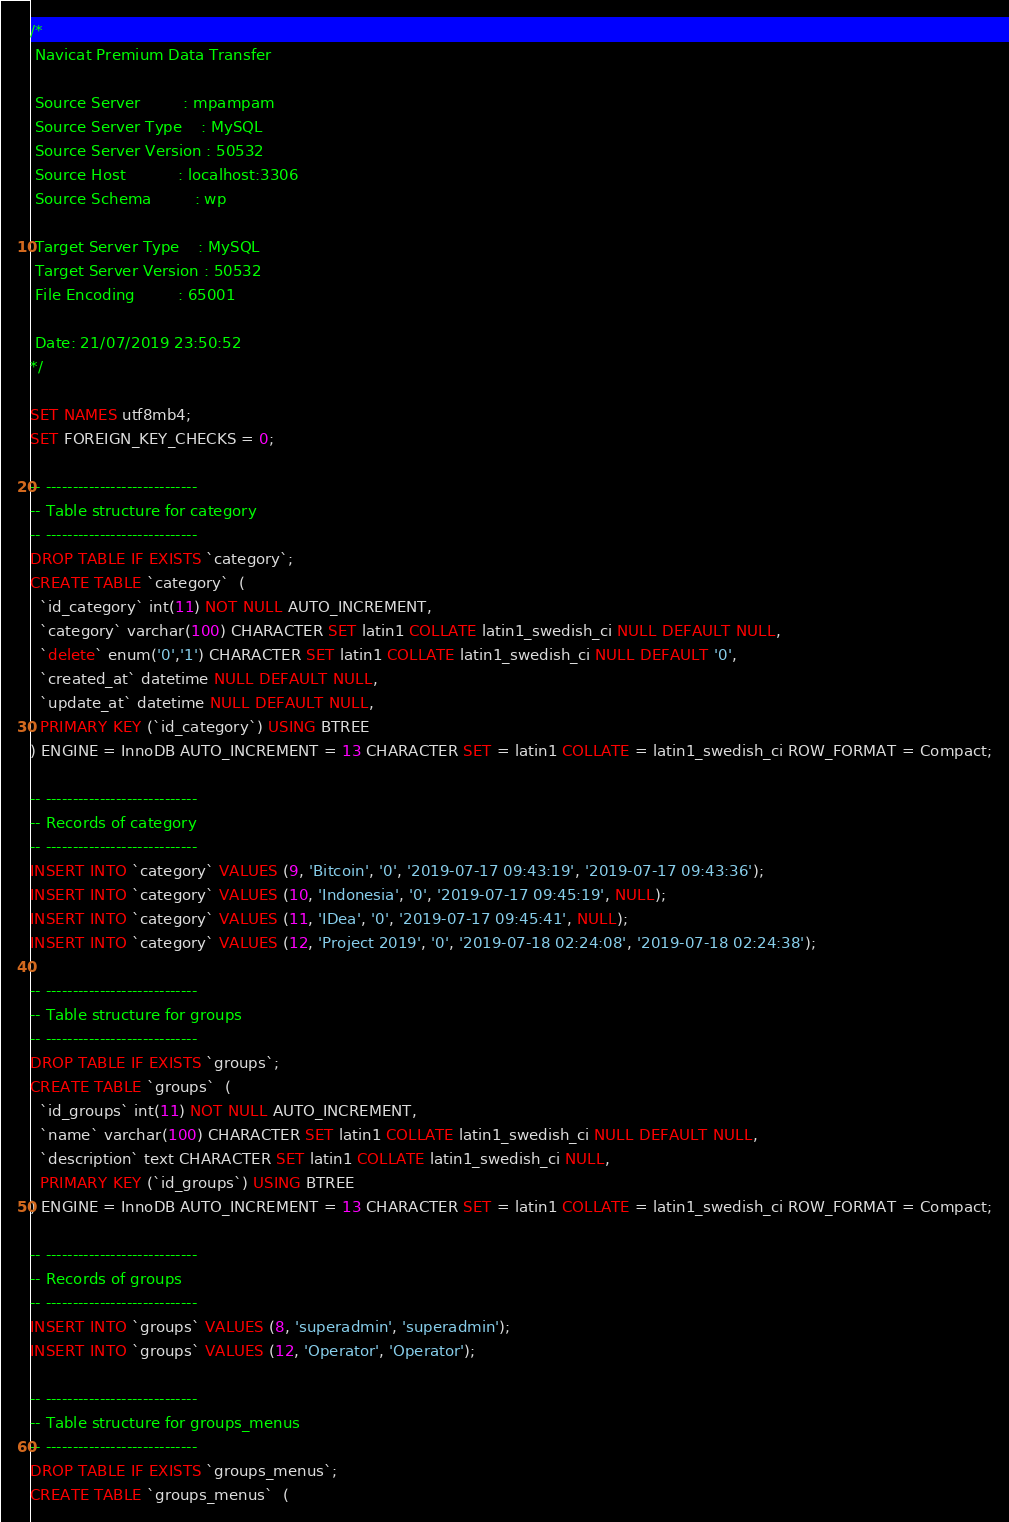Convert code to text. <code><loc_0><loc_0><loc_500><loc_500><_SQL_>/*
 Navicat Premium Data Transfer

 Source Server         : mpampam
 Source Server Type    : MySQL
 Source Server Version : 50532
 Source Host           : localhost:3306
 Source Schema         : wp

 Target Server Type    : MySQL
 Target Server Version : 50532
 File Encoding         : 65001

 Date: 21/07/2019 23:50:52
*/

SET NAMES utf8mb4;
SET FOREIGN_KEY_CHECKS = 0;

-- ----------------------------
-- Table structure for category
-- ----------------------------
DROP TABLE IF EXISTS `category`;
CREATE TABLE `category`  (
  `id_category` int(11) NOT NULL AUTO_INCREMENT,
  `category` varchar(100) CHARACTER SET latin1 COLLATE latin1_swedish_ci NULL DEFAULT NULL,
  `delete` enum('0','1') CHARACTER SET latin1 COLLATE latin1_swedish_ci NULL DEFAULT '0',
  `created_at` datetime NULL DEFAULT NULL,
  `update_at` datetime NULL DEFAULT NULL,
  PRIMARY KEY (`id_category`) USING BTREE
) ENGINE = InnoDB AUTO_INCREMENT = 13 CHARACTER SET = latin1 COLLATE = latin1_swedish_ci ROW_FORMAT = Compact;

-- ----------------------------
-- Records of category
-- ----------------------------
INSERT INTO `category` VALUES (9, 'Bitcoin', '0', '2019-07-17 09:43:19', '2019-07-17 09:43:36');
INSERT INTO `category` VALUES (10, 'Indonesia', '0', '2019-07-17 09:45:19', NULL);
INSERT INTO `category` VALUES (11, 'IDea', '0', '2019-07-17 09:45:41', NULL);
INSERT INTO `category` VALUES (12, 'Project 2019', '0', '2019-07-18 02:24:08', '2019-07-18 02:24:38');

-- ----------------------------
-- Table structure for groups
-- ----------------------------
DROP TABLE IF EXISTS `groups`;
CREATE TABLE `groups`  (
  `id_groups` int(11) NOT NULL AUTO_INCREMENT,
  `name` varchar(100) CHARACTER SET latin1 COLLATE latin1_swedish_ci NULL DEFAULT NULL,
  `description` text CHARACTER SET latin1 COLLATE latin1_swedish_ci NULL,
  PRIMARY KEY (`id_groups`) USING BTREE
) ENGINE = InnoDB AUTO_INCREMENT = 13 CHARACTER SET = latin1 COLLATE = latin1_swedish_ci ROW_FORMAT = Compact;

-- ----------------------------
-- Records of groups
-- ----------------------------
INSERT INTO `groups` VALUES (8, 'superadmin', 'superadmin');
INSERT INTO `groups` VALUES (12, 'Operator', 'Operator');

-- ----------------------------
-- Table structure for groups_menus
-- ----------------------------
DROP TABLE IF EXISTS `groups_menus`;
CREATE TABLE `groups_menus`  (</code> 